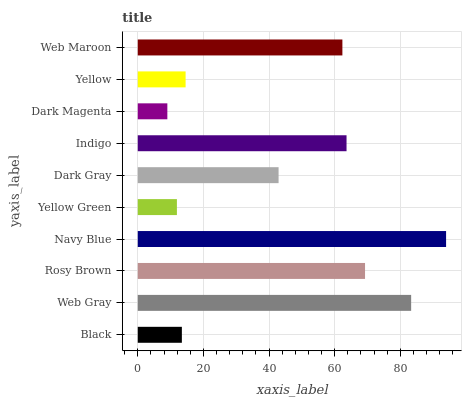Is Dark Magenta the minimum?
Answer yes or no. Yes. Is Navy Blue the maximum?
Answer yes or no. Yes. Is Web Gray the minimum?
Answer yes or no. No. Is Web Gray the maximum?
Answer yes or no. No. Is Web Gray greater than Black?
Answer yes or no. Yes. Is Black less than Web Gray?
Answer yes or no. Yes. Is Black greater than Web Gray?
Answer yes or no. No. Is Web Gray less than Black?
Answer yes or no. No. Is Web Maroon the high median?
Answer yes or no. Yes. Is Dark Gray the low median?
Answer yes or no. Yes. Is Dark Gray the high median?
Answer yes or no. No. Is Yellow Green the low median?
Answer yes or no. No. 